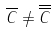<formula> <loc_0><loc_0><loc_500><loc_500>\overline { C } \ne \overline { \overline { C } }</formula> 